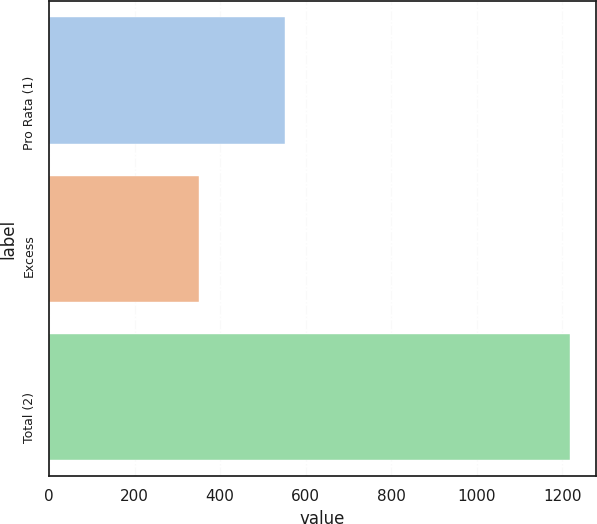Convert chart. <chart><loc_0><loc_0><loc_500><loc_500><bar_chart><fcel>Pro Rata (1)<fcel>Excess<fcel>Total (2)<nl><fcel>551.8<fcel>350.6<fcel>1218.3<nl></chart> 